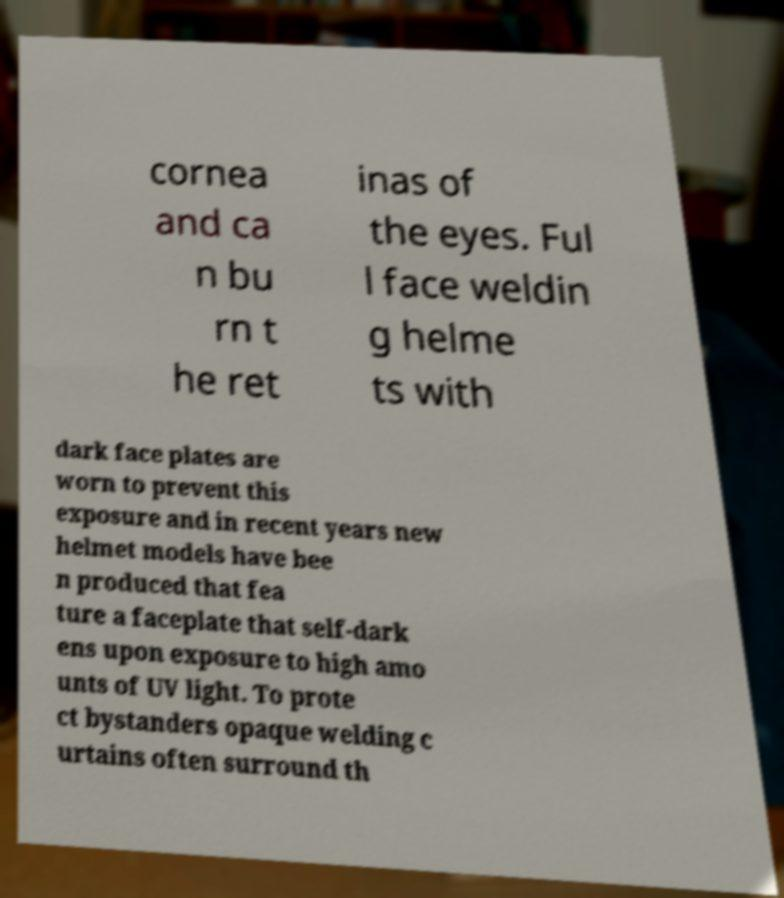There's text embedded in this image that I need extracted. Can you transcribe it verbatim? cornea and ca n bu rn t he ret inas of the eyes. Ful l face weldin g helme ts with dark face plates are worn to prevent this exposure and in recent years new helmet models have bee n produced that fea ture a faceplate that self-dark ens upon exposure to high amo unts of UV light. To prote ct bystanders opaque welding c urtains often surround th 